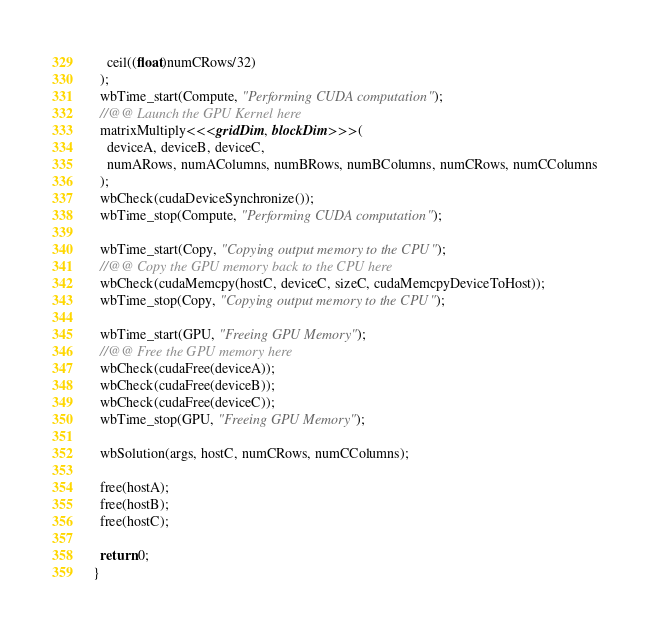<code> <loc_0><loc_0><loc_500><loc_500><_Cuda_>    ceil((float)numCRows/32)
  );
  wbTime_start(Compute, "Performing CUDA computation");
  //@@ Launch the GPU Kernel here
  matrixMultiply<<<gridDim, blockDim>>>(
    deviceA, deviceB, deviceC,
    numARows, numAColumns, numBRows, numBColumns, numCRows, numCColumns
  );
  wbCheck(cudaDeviceSynchronize());
  wbTime_stop(Compute, "Performing CUDA computation");

  wbTime_start(Copy, "Copying output memory to the CPU");
  //@@ Copy the GPU memory back to the CPU here
  wbCheck(cudaMemcpy(hostC, deviceC, sizeC, cudaMemcpyDeviceToHost));
  wbTime_stop(Copy, "Copying output memory to the CPU");

  wbTime_start(GPU, "Freeing GPU Memory");
  //@@ Free the GPU memory here
  wbCheck(cudaFree(deviceA));
  wbCheck(cudaFree(deviceB));
  wbCheck(cudaFree(deviceC));
  wbTime_stop(GPU, "Freeing GPU Memory");

  wbSolution(args, hostC, numCRows, numCColumns);

  free(hostA);
  free(hostB);
  free(hostC);

  return 0;
}
</code> 